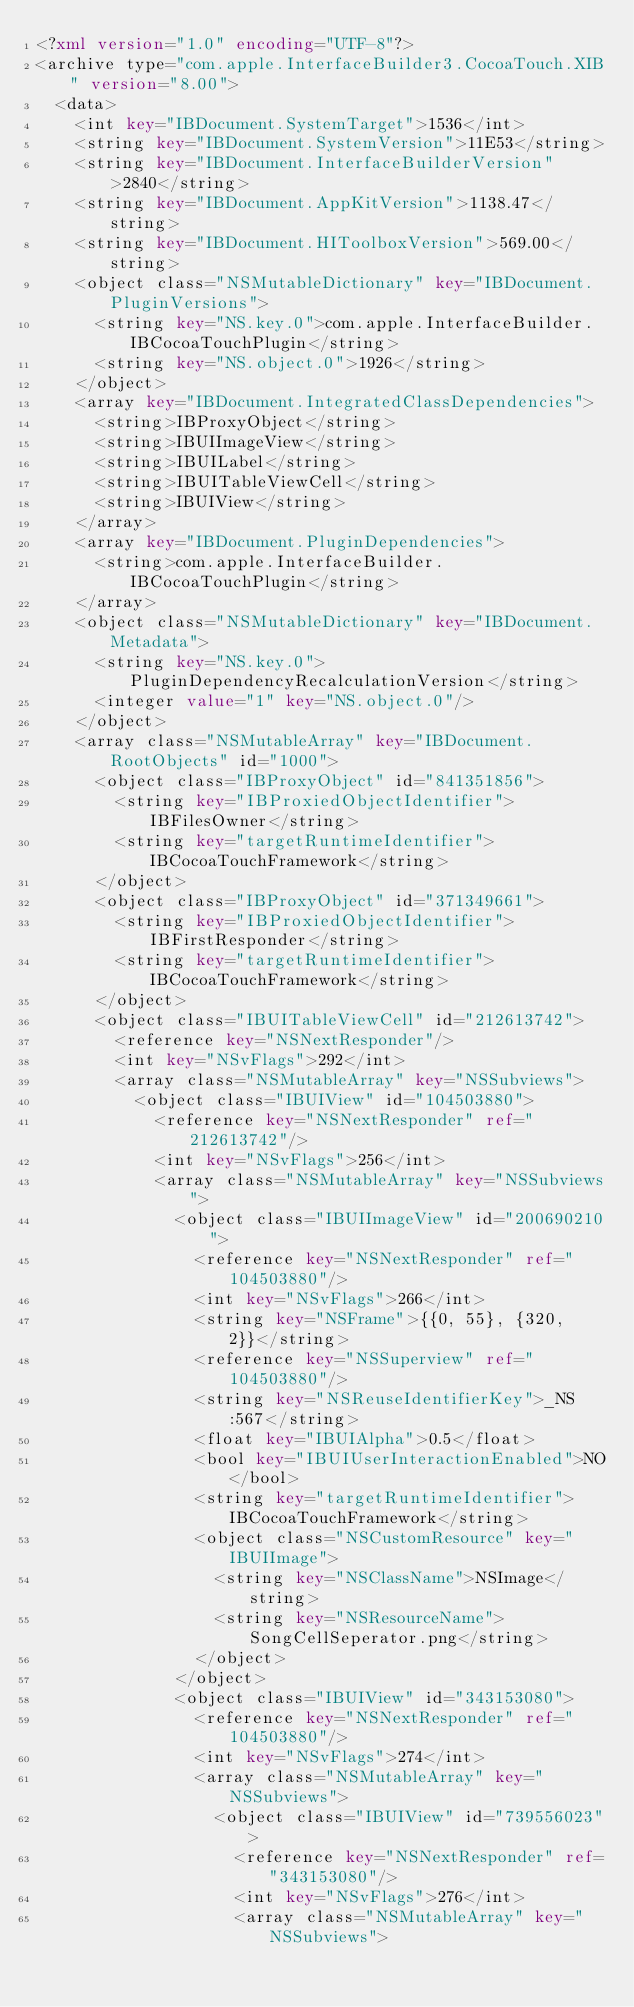Convert code to text. <code><loc_0><loc_0><loc_500><loc_500><_XML_><?xml version="1.0" encoding="UTF-8"?>
<archive type="com.apple.InterfaceBuilder3.CocoaTouch.XIB" version="8.00">
	<data>
		<int key="IBDocument.SystemTarget">1536</int>
		<string key="IBDocument.SystemVersion">11E53</string>
		<string key="IBDocument.InterfaceBuilderVersion">2840</string>
		<string key="IBDocument.AppKitVersion">1138.47</string>
		<string key="IBDocument.HIToolboxVersion">569.00</string>
		<object class="NSMutableDictionary" key="IBDocument.PluginVersions">
			<string key="NS.key.0">com.apple.InterfaceBuilder.IBCocoaTouchPlugin</string>
			<string key="NS.object.0">1926</string>
		</object>
		<array key="IBDocument.IntegratedClassDependencies">
			<string>IBProxyObject</string>
			<string>IBUIImageView</string>
			<string>IBUILabel</string>
			<string>IBUITableViewCell</string>
			<string>IBUIView</string>
		</array>
		<array key="IBDocument.PluginDependencies">
			<string>com.apple.InterfaceBuilder.IBCocoaTouchPlugin</string>
		</array>
		<object class="NSMutableDictionary" key="IBDocument.Metadata">
			<string key="NS.key.0">PluginDependencyRecalculationVersion</string>
			<integer value="1" key="NS.object.0"/>
		</object>
		<array class="NSMutableArray" key="IBDocument.RootObjects" id="1000">
			<object class="IBProxyObject" id="841351856">
				<string key="IBProxiedObjectIdentifier">IBFilesOwner</string>
				<string key="targetRuntimeIdentifier">IBCocoaTouchFramework</string>
			</object>
			<object class="IBProxyObject" id="371349661">
				<string key="IBProxiedObjectIdentifier">IBFirstResponder</string>
				<string key="targetRuntimeIdentifier">IBCocoaTouchFramework</string>
			</object>
			<object class="IBUITableViewCell" id="212613742">
				<reference key="NSNextResponder"/>
				<int key="NSvFlags">292</int>
				<array class="NSMutableArray" key="NSSubviews">
					<object class="IBUIView" id="104503880">
						<reference key="NSNextResponder" ref="212613742"/>
						<int key="NSvFlags">256</int>
						<array class="NSMutableArray" key="NSSubviews">
							<object class="IBUIImageView" id="200690210">
								<reference key="NSNextResponder" ref="104503880"/>
								<int key="NSvFlags">266</int>
								<string key="NSFrame">{{0, 55}, {320, 2}}</string>
								<reference key="NSSuperview" ref="104503880"/>
								<string key="NSReuseIdentifierKey">_NS:567</string>
								<float key="IBUIAlpha">0.5</float>
								<bool key="IBUIUserInteractionEnabled">NO</bool>
								<string key="targetRuntimeIdentifier">IBCocoaTouchFramework</string>
								<object class="NSCustomResource" key="IBUIImage">
									<string key="NSClassName">NSImage</string>
									<string key="NSResourceName">SongCellSeperator.png</string>
								</object>
							</object>
							<object class="IBUIView" id="343153080">
								<reference key="NSNextResponder" ref="104503880"/>
								<int key="NSvFlags">274</int>
								<array class="NSMutableArray" key="NSSubviews">
									<object class="IBUIView" id="739556023">
										<reference key="NSNextResponder" ref="343153080"/>
										<int key="NSvFlags">276</int>
										<array class="NSMutableArray" key="NSSubviews"></code> 